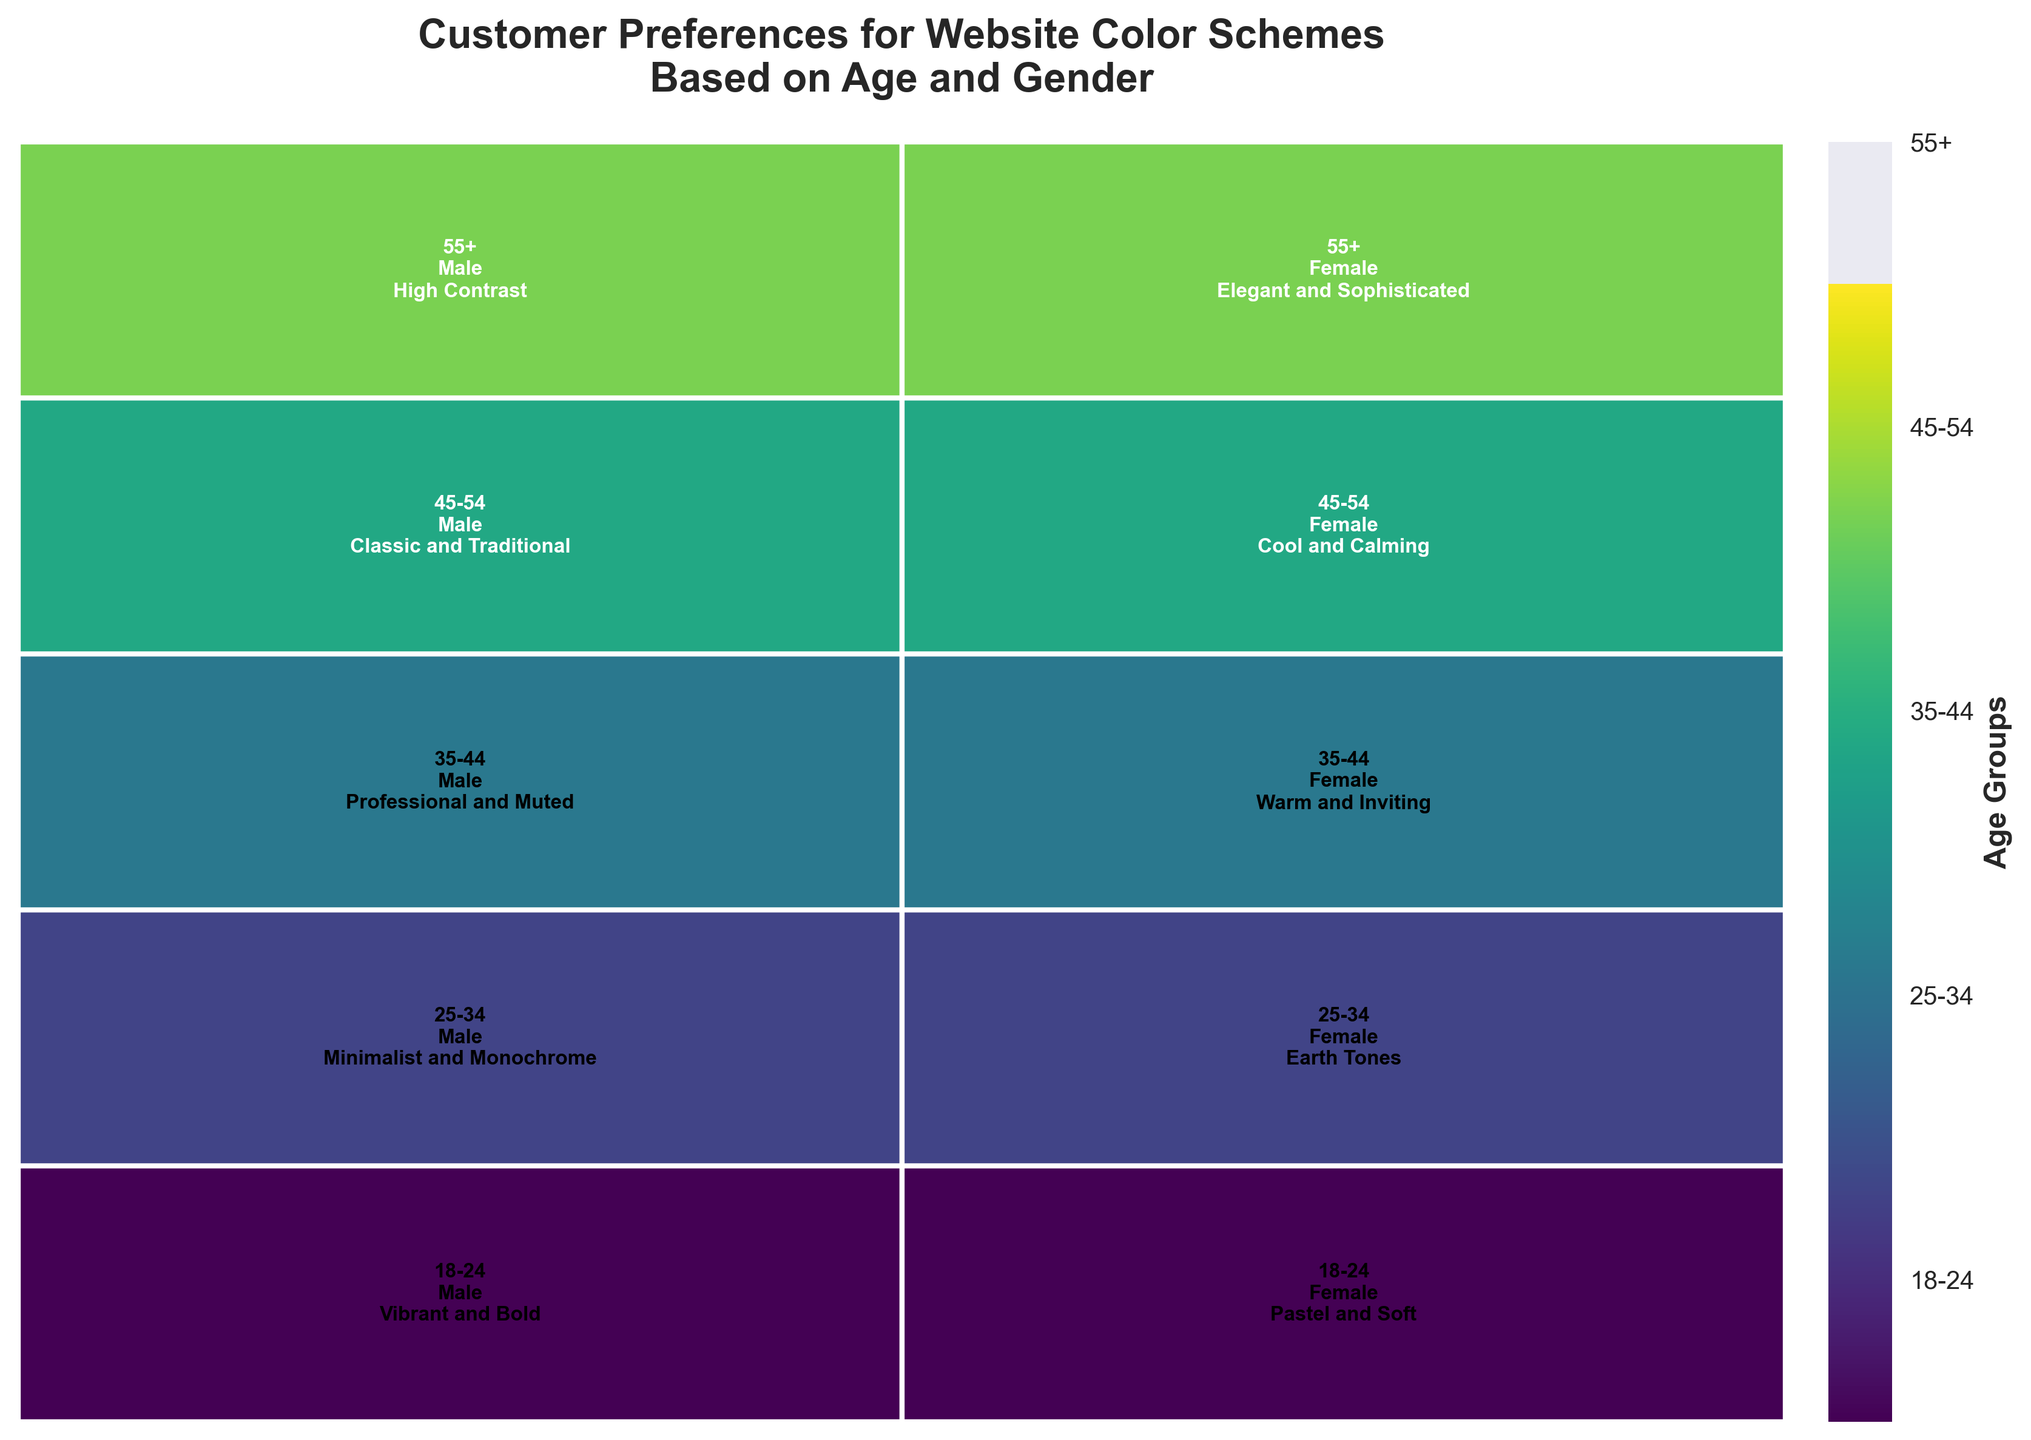What is the title of the mosaic plot? The title of the mosaic plot is located at the top and provides an overview of what the plot represents. Reading the title helps understand the context of the data being visualized.
Answer: Customer Preferences for Website Color Schemes Based on Age and Gender How many age groups are represented in the plot? Count the number of distinct labels along the color bar legend on the right side of the plot, each representing a unique age group.
Answer: Five Which age group has the widest section in the mosaic plot? Observe the width of the sections for each age group along the x-axis in the plot. The age group with the widest section indicates it has the highest proportion of data.
Answer: 18-24 What color scheme is preferred by 45-54-year-old females? Locate the section in the mosaic plot corresponding to 45-54 years and females, and read the text label inside the section.
Answer: Cool and Calming Which gender prefers the "High Contrast" color scheme and in which age group? Find the text label "High Contrast" in the mosaic plot and check the corresponding gender and age group in the same section.
Answer: Male, 55+ Compare the preferred color schemes between males aged 25-34 and males aged 35-44. How do they differ? Locate the sections in the mosaic plot for males in the age groups 25-34 and 35-44, read the color scheme labels in each section, and compare them.
Answer: Minimalist and Monochrome vs. Professional and Muted Which gender has a preference for "Earth Tones" and in which age group? Find the text label "Earth Tones" in the mosaic plot and identify the associated gender and age group in that section.
Answer: Female, 25-34 Are there any age groups where both males and females prefer similar color schemes? Methodically check each age group in the mosaic plot and compare the color scheme labels for both genders within the same age group to see if they match.
Answer: No Calculate the proportion of the mosaic plot taken up by the age group 35-44. Sum the widths of the sections corresponding to age group 35-44 for both genders from the plot’s x-axis. The total width represents the proportion of that age group.
Answer: Approximately 20% How does the preference for "Warm and Inviting" color schemes differ between genders and age groups? Identify sections in the mosaic plot labeled with "Warm and Inviting" and note the corresponding gender and age group for each occurrence, comparing them.
Answer: Only preferred by females aged 35-44 